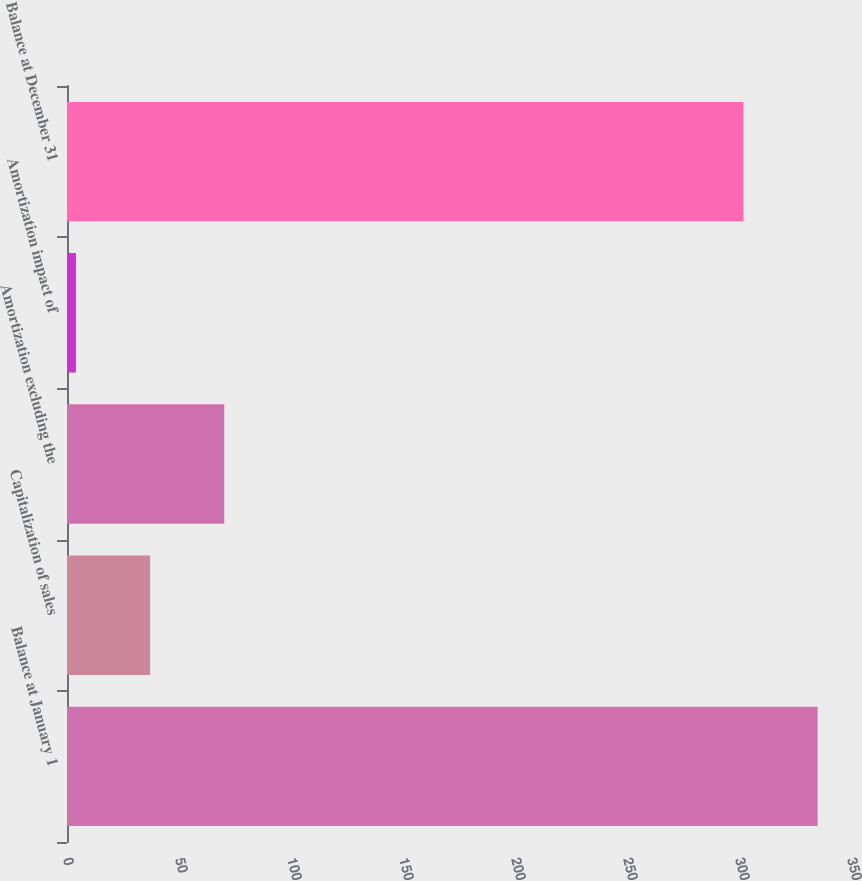Convert chart to OTSL. <chart><loc_0><loc_0><loc_500><loc_500><bar_chart><fcel>Balance at January 1<fcel>Capitalization of sales<fcel>Amortization excluding the<fcel>Amortization impact of<fcel>Balance at December 31<nl><fcel>335.1<fcel>37.1<fcel>70.2<fcel>4<fcel>302<nl></chart> 